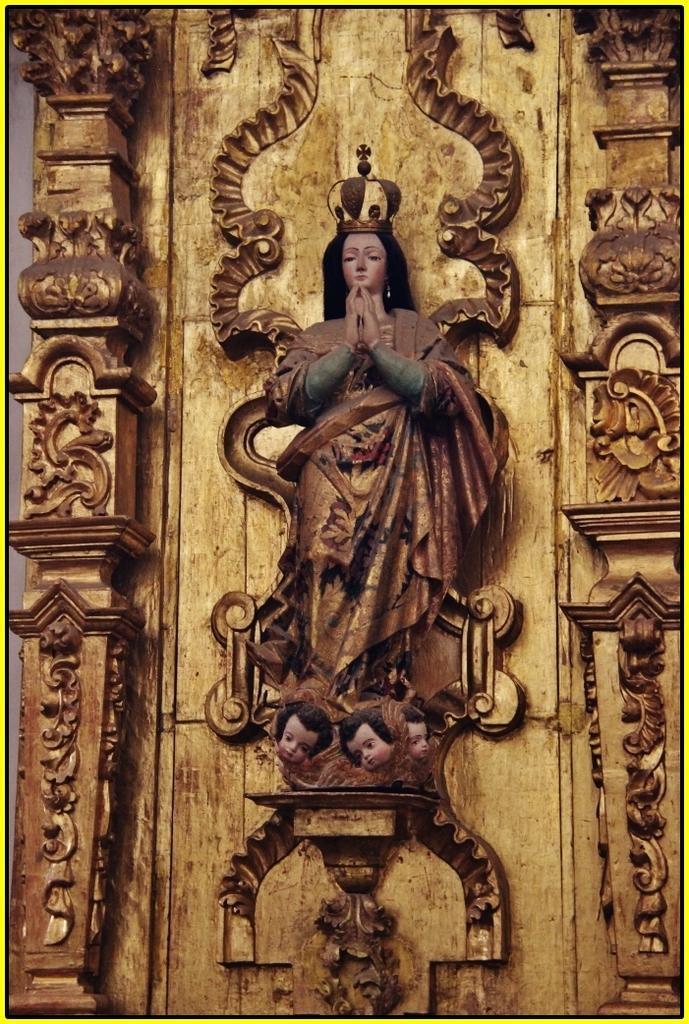In one or two sentences, can you explain what this image depicts? In this image we can see statue to the wall and sculptures on the pillars. 